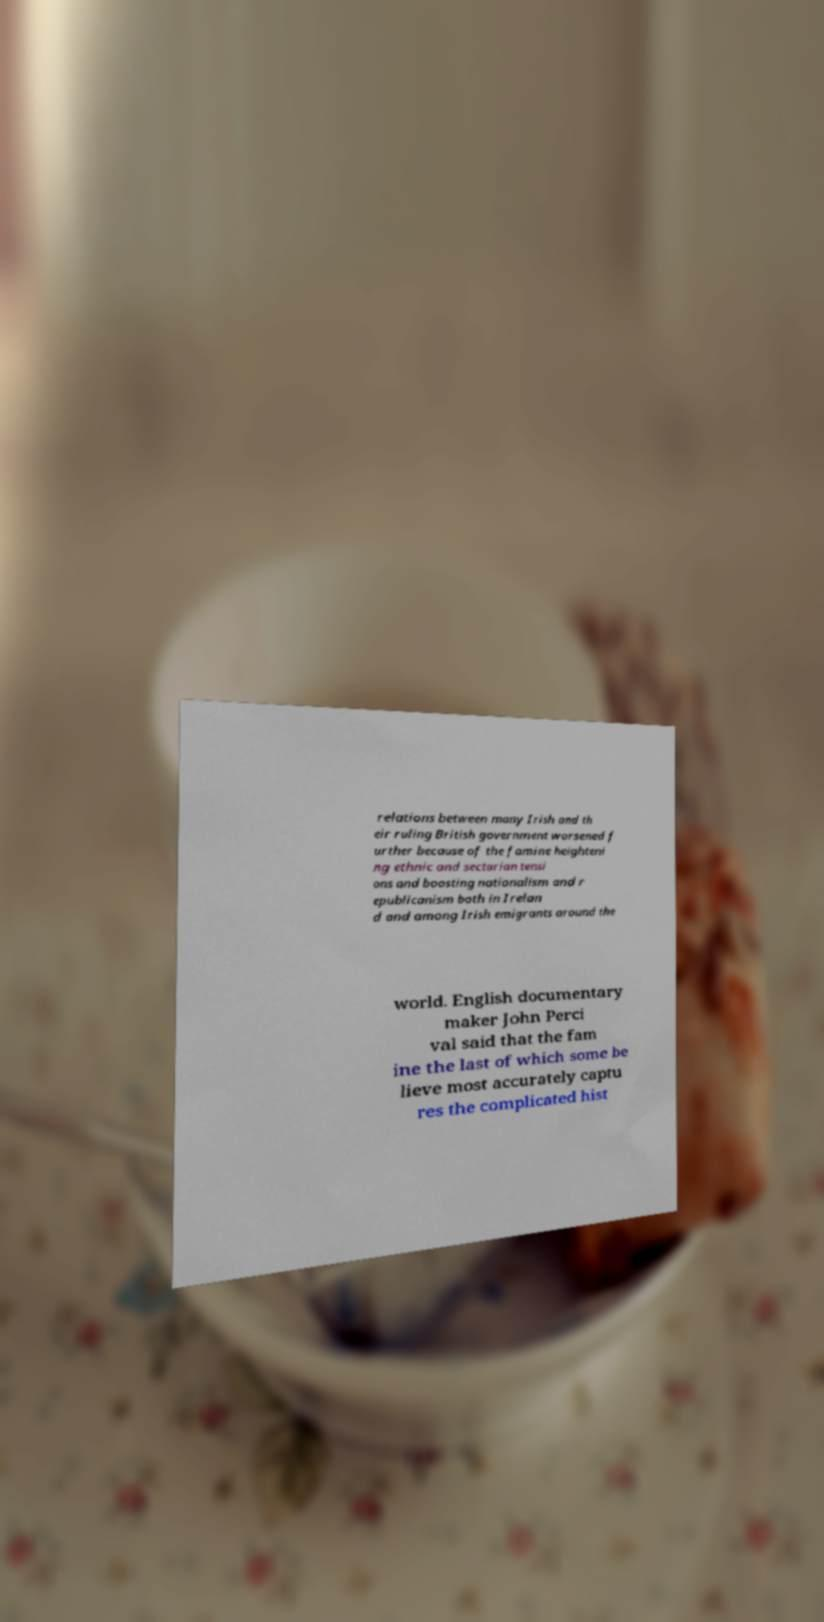Can you accurately transcribe the text from the provided image for me? relations between many Irish and th eir ruling British government worsened f urther because of the famine heighteni ng ethnic and sectarian tensi ons and boosting nationalism and r epublicanism both in Irelan d and among Irish emigrants around the world. English documentary maker John Perci val said that the fam ine the last of which some be lieve most accurately captu res the complicated hist 